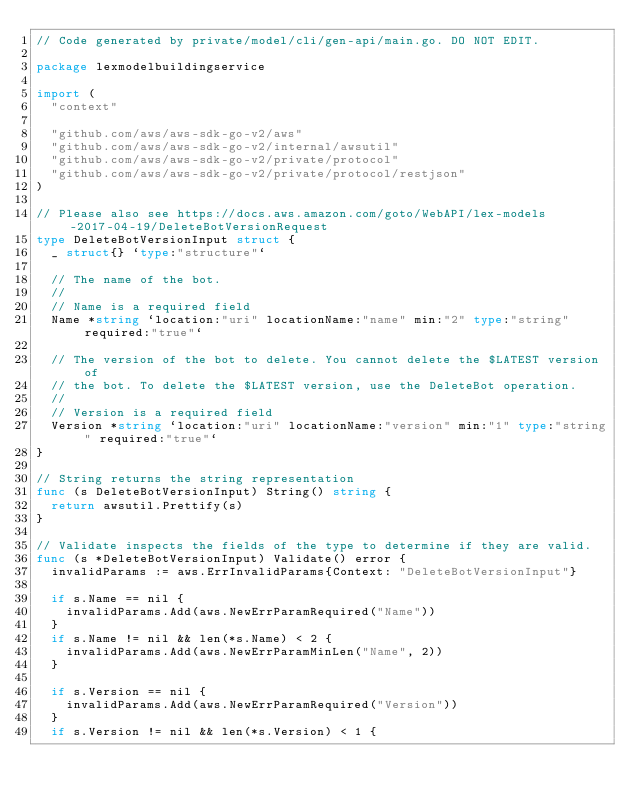Convert code to text. <code><loc_0><loc_0><loc_500><loc_500><_Go_>// Code generated by private/model/cli/gen-api/main.go. DO NOT EDIT.

package lexmodelbuildingservice

import (
	"context"

	"github.com/aws/aws-sdk-go-v2/aws"
	"github.com/aws/aws-sdk-go-v2/internal/awsutil"
	"github.com/aws/aws-sdk-go-v2/private/protocol"
	"github.com/aws/aws-sdk-go-v2/private/protocol/restjson"
)

// Please also see https://docs.aws.amazon.com/goto/WebAPI/lex-models-2017-04-19/DeleteBotVersionRequest
type DeleteBotVersionInput struct {
	_ struct{} `type:"structure"`

	// The name of the bot.
	//
	// Name is a required field
	Name *string `location:"uri" locationName:"name" min:"2" type:"string" required:"true"`

	// The version of the bot to delete. You cannot delete the $LATEST version of
	// the bot. To delete the $LATEST version, use the DeleteBot operation.
	//
	// Version is a required field
	Version *string `location:"uri" locationName:"version" min:"1" type:"string" required:"true"`
}

// String returns the string representation
func (s DeleteBotVersionInput) String() string {
	return awsutil.Prettify(s)
}

// Validate inspects the fields of the type to determine if they are valid.
func (s *DeleteBotVersionInput) Validate() error {
	invalidParams := aws.ErrInvalidParams{Context: "DeleteBotVersionInput"}

	if s.Name == nil {
		invalidParams.Add(aws.NewErrParamRequired("Name"))
	}
	if s.Name != nil && len(*s.Name) < 2 {
		invalidParams.Add(aws.NewErrParamMinLen("Name", 2))
	}

	if s.Version == nil {
		invalidParams.Add(aws.NewErrParamRequired("Version"))
	}
	if s.Version != nil && len(*s.Version) < 1 {</code> 